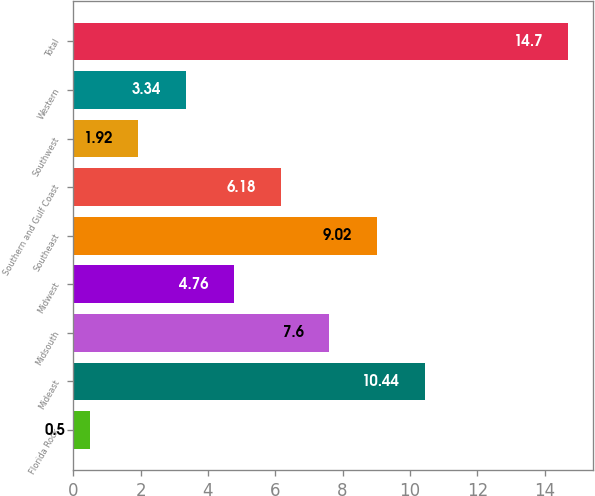Convert chart to OTSL. <chart><loc_0><loc_0><loc_500><loc_500><bar_chart><fcel>Florida Rock<fcel>Mideast<fcel>Midsouth<fcel>Midwest<fcel>Southeast<fcel>Southern and Gulf Coast<fcel>Southwest<fcel>Western<fcel>Total<nl><fcel>0.5<fcel>10.44<fcel>7.6<fcel>4.76<fcel>9.02<fcel>6.18<fcel>1.92<fcel>3.34<fcel>14.7<nl></chart> 